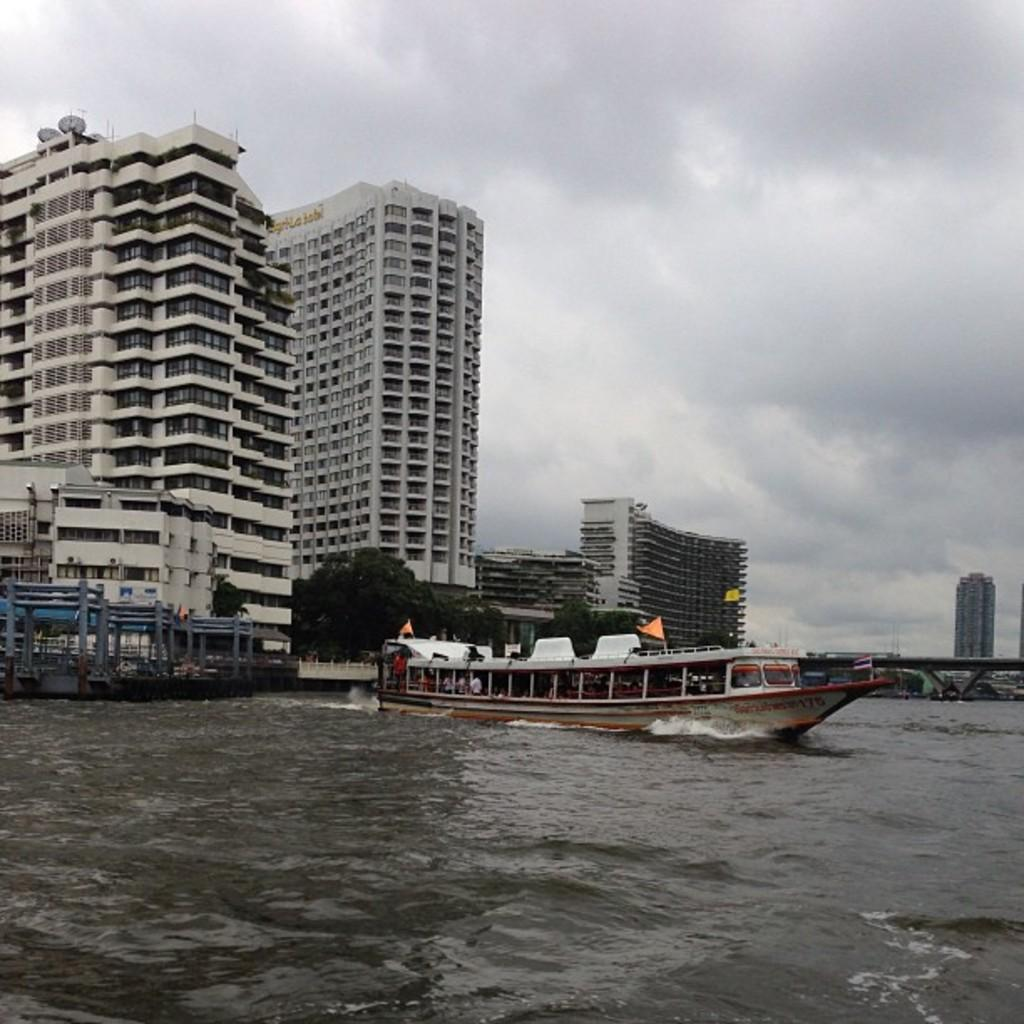What type of structures can be seen in the image? There are buildings in the image. What feature do the buildings have? The buildings have glass windows. What other natural elements are present in the image? There are trees in the image. What man-made objects can be seen in the water? There are boats in the image. What is the water body in the image? There is water visible in the image. What connects the two sides of the water body? There is a bridge in the image. What is the color of the sky in the image? The sky appears to be white in color. What type of religion is practiced in the image? There is no indication of any religious practice or belief in the image. What type of coach is present in the image? There is no coach present in the image. 